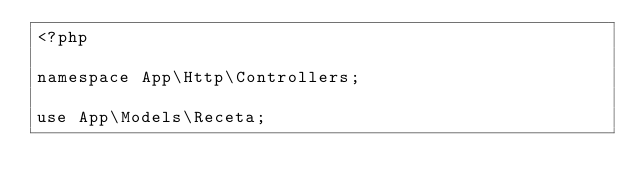Convert code to text. <code><loc_0><loc_0><loc_500><loc_500><_PHP_><?php

namespace App\Http\Controllers;

use App\Models\Receta;</code> 